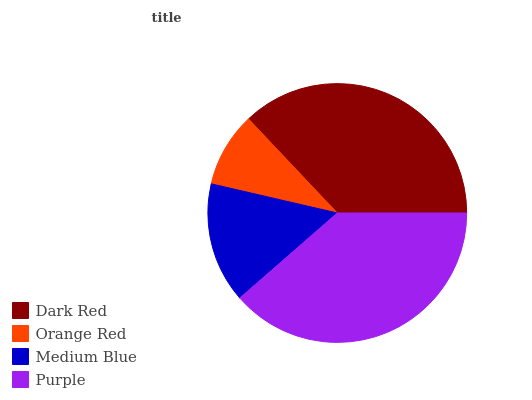Is Orange Red the minimum?
Answer yes or no. Yes. Is Purple the maximum?
Answer yes or no. Yes. Is Medium Blue the minimum?
Answer yes or no. No. Is Medium Blue the maximum?
Answer yes or no. No. Is Medium Blue greater than Orange Red?
Answer yes or no. Yes. Is Orange Red less than Medium Blue?
Answer yes or no. Yes. Is Orange Red greater than Medium Blue?
Answer yes or no. No. Is Medium Blue less than Orange Red?
Answer yes or no. No. Is Dark Red the high median?
Answer yes or no. Yes. Is Medium Blue the low median?
Answer yes or no. Yes. Is Orange Red the high median?
Answer yes or no. No. Is Purple the low median?
Answer yes or no. No. 